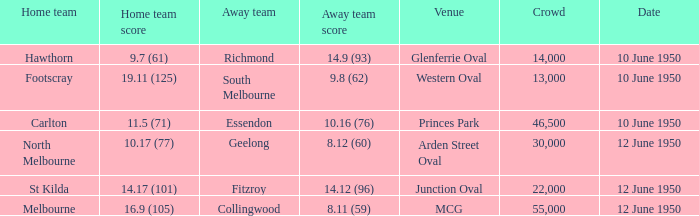What was the audience when melbourne was the host team? 55000.0. 